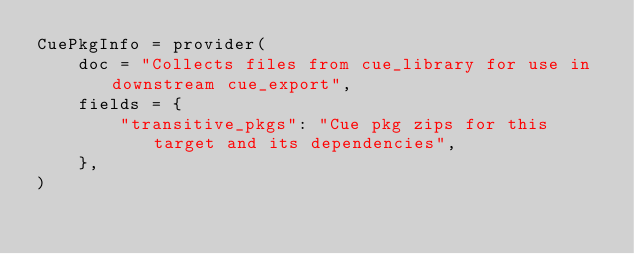Convert code to text. <code><loc_0><loc_0><loc_500><loc_500><_Python_>CuePkgInfo = provider(
    doc = "Collects files from cue_library for use in downstream cue_export",
    fields = {
        "transitive_pkgs": "Cue pkg zips for this target and its dependencies",
    },
)
</code> 